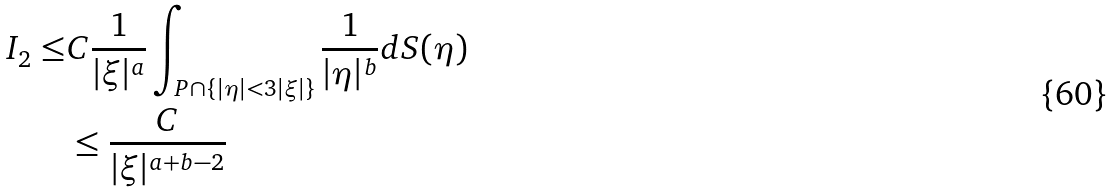<formula> <loc_0><loc_0><loc_500><loc_500>I _ { 2 } \leq & C \frac { 1 } { | \xi | ^ { a } } \int _ { P \cap \{ | \eta | < 3 | \xi | \} } \frac { 1 } { | \eta | ^ { b } } d S ( \eta ) \\ & \leq \frac { C } { | \xi | ^ { a + b - 2 } }</formula> 